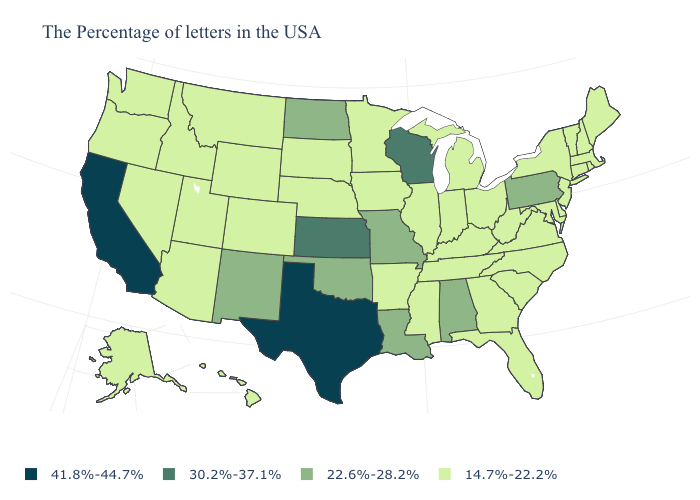Name the states that have a value in the range 30.2%-37.1%?
Write a very short answer. Wisconsin, Kansas. What is the value of Iowa?
Be succinct. 14.7%-22.2%. What is the highest value in states that border Florida?
Give a very brief answer. 22.6%-28.2%. Among the states that border Colorado , which have the highest value?
Short answer required. Kansas. Among the states that border Connecticut , which have the highest value?
Short answer required. Massachusetts, Rhode Island, New York. Does Arizona have a lower value than Oklahoma?
Give a very brief answer. Yes. How many symbols are there in the legend?
Short answer required. 4. How many symbols are there in the legend?
Write a very short answer. 4. Does Oregon have the same value as Wisconsin?
Answer briefly. No. Is the legend a continuous bar?
Answer briefly. No. Does Hawaii have the lowest value in the West?
Be succinct. Yes. How many symbols are there in the legend?
Give a very brief answer. 4. What is the value of Minnesota?
Give a very brief answer. 14.7%-22.2%. What is the lowest value in the USA?
Answer briefly. 14.7%-22.2%. What is the highest value in the USA?
Quick response, please. 41.8%-44.7%. 